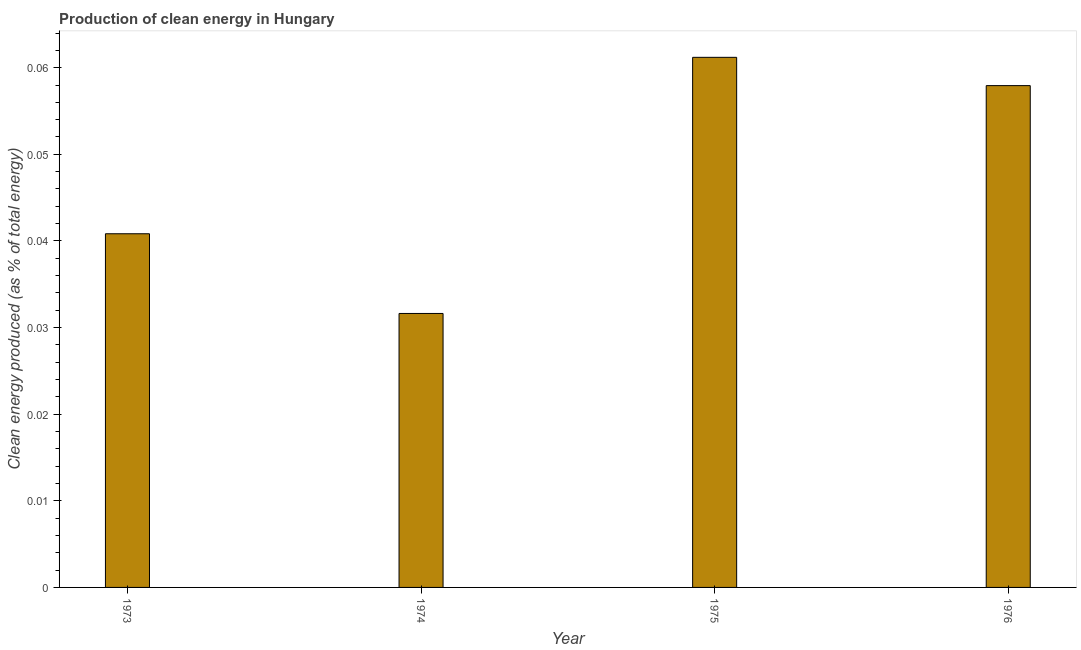Does the graph contain grids?
Your response must be concise. No. What is the title of the graph?
Your response must be concise. Production of clean energy in Hungary. What is the label or title of the Y-axis?
Your answer should be compact. Clean energy produced (as % of total energy). What is the production of clean energy in 1973?
Your response must be concise. 0.04. Across all years, what is the maximum production of clean energy?
Offer a terse response. 0.06. Across all years, what is the minimum production of clean energy?
Provide a short and direct response. 0.03. In which year was the production of clean energy maximum?
Provide a succinct answer. 1975. In which year was the production of clean energy minimum?
Provide a short and direct response. 1974. What is the sum of the production of clean energy?
Offer a terse response. 0.19. What is the difference between the production of clean energy in 1973 and 1974?
Offer a very short reply. 0.01. What is the average production of clean energy per year?
Ensure brevity in your answer.  0.05. What is the median production of clean energy?
Offer a very short reply. 0.05. What is the ratio of the production of clean energy in 1973 to that in 1975?
Give a very brief answer. 0.67. Is the production of clean energy in 1974 less than that in 1976?
Ensure brevity in your answer.  Yes. Is the difference between the production of clean energy in 1973 and 1975 greater than the difference between any two years?
Your answer should be very brief. No. What is the difference between the highest and the second highest production of clean energy?
Your answer should be very brief. 0. How many bars are there?
Offer a very short reply. 4. Are all the bars in the graph horizontal?
Your response must be concise. No. How many years are there in the graph?
Make the answer very short. 4. What is the difference between two consecutive major ticks on the Y-axis?
Ensure brevity in your answer.  0.01. Are the values on the major ticks of Y-axis written in scientific E-notation?
Keep it short and to the point. No. What is the Clean energy produced (as % of total energy) in 1973?
Keep it short and to the point. 0.04. What is the Clean energy produced (as % of total energy) in 1974?
Ensure brevity in your answer.  0.03. What is the Clean energy produced (as % of total energy) of 1975?
Give a very brief answer. 0.06. What is the Clean energy produced (as % of total energy) of 1976?
Provide a short and direct response. 0.06. What is the difference between the Clean energy produced (as % of total energy) in 1973 and 1974?
Give a very brief answer. 0.01. What is the difference between the Clean energy produced (as % of total energy) in 1973 and 1975?
Make the answer very short. -0.02. What is the difference between the Clean energy produced (as % of total energy) in 1973 and 1976?
Your answer should be compact. -0.02. What is the difference between the Clean energy produced (as % of total energy) in 1974 and 1975?
Provide a short and direct response. -0.03. What is the difference between the Clean energy produced (as % of total energy) in 1974 and 1976?
Ensure brevity in your answer.  -0.03. What is the difference between the Clean energy produced (as % of total energy) in 1975 and 1976?
Your response must be concise. 0. What is the ratio of the Clean energy produced (as % of total energy) in 1973 to that in 1974?
Ensure brevity in your answer.  1.29. What is the ratio of the Clean energy produced (as % of total energy) in 1973 to that in 1975?
Offer a terse response. 0.67. What is the ratio of the Clean energy produced (as % of total energy) in 1973 to that in 1976?
Make the answer very short. 0.7. What is the ratio of the Clean energy produced (as % of total energy) in 1974 to that in 1975?
Make the answer very short. 0.52. What is the ratio of the Clean energy produced (as % of total energy) in 1974 to that in 1976?
Your response must be concise. 0.55. What is the ratio of the Clean energy produced (as % of total energy) in 1975 to that in 1976?
Provide a short and direct response. 1.06. 